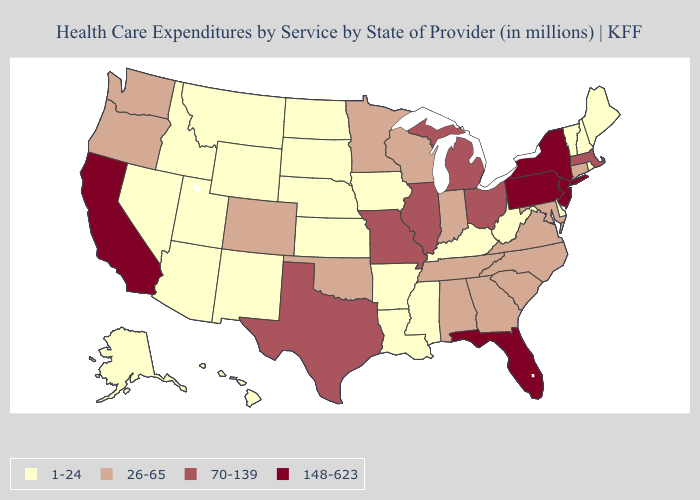What is the lowest value in the USA?
Short answer required. 1-24. What is the highest value in states that border Wisconsin?
Quick response, please. 70-139. Does New York have the same value as South Carolina?
Be succinct. No. What is the value of Illinois?
Concise answer only. 70-139. Among the states that border Colorado , which have the highest value?
Concise answer only. Oklahoma. Name the states that have a value in the range 26-65?
Keep it brief. Alabama, Colorado, Connecticut, Georgia, Indiana, Maryland, Minnesota, North Carolina, Oklahoma, Oregon, South Carolina, Tennessee, Virginia, Washington, Wisconsin. What is the highest value in states that border Michigan?
Write a very short answer. 70-139. Name the states that have a value in the range 148-623?
Quick response, please. California, Florida, New Jersey, New York, Pennsylvania. Does the first symbol in the legend represent the smallest category?
Short answer required. Yes. Among the states that border Maine , which have the highest value?
Be succinct. New Hampshire. What is the lowest value in states that border West Virginia?
Concise answer only. 1-24. What is the value of New Mexico?
Concise answer only. 1-24. Does the first symbol in the legend represent the smallest category?
Write a very short answer. Yes. Does the map have missing data?
Write a very short answer. No. What is the value of Arizona?
Concise answer only. 1-24. 